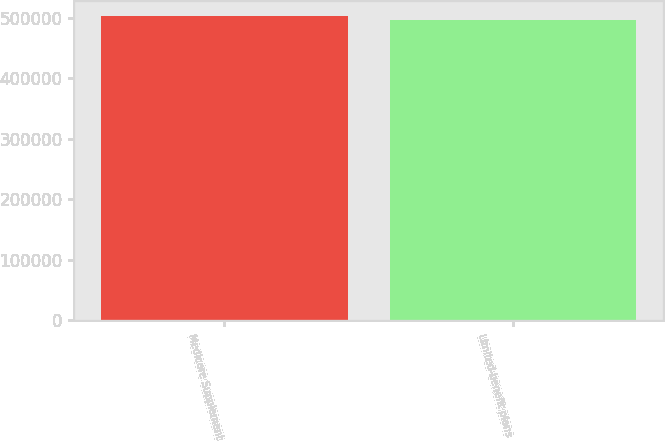<chart> <loc_0><loc_0><loc_500><loc_500><bar_chart><fcel>Medicare Supplement<fcel>Limited-benefit plans<nl><fcel>502691<fcel>495943<nl></chart> 